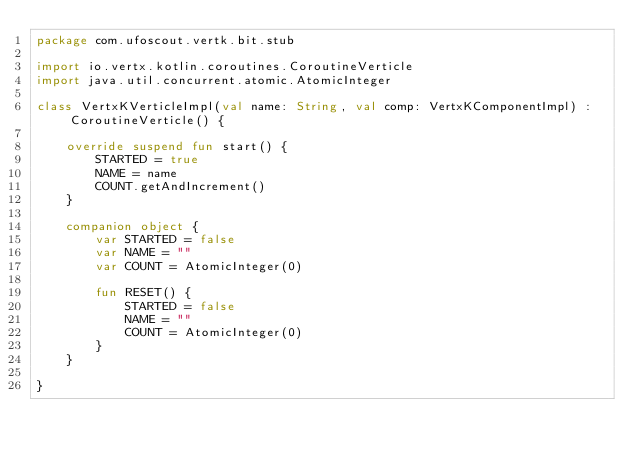<code> <loc_0><loc_0><loc_500><loc_500><_Kotlin_>package com.ufoscout.vertk.bit.stub

import io.vertx.kotlin.coroutines.CoroutineVerticle
import java.util.concurrent.atomic.AtomicInteger

class VertxKVerticleImpl(val name: String, val comp: VertxKComponentImpl) : CoroutineVerticle() {

    override suspend fun start() {
        STARTED = true
        NAME = name
        COUNT.getAndIncrement()
    }

    companion object {
        var STARTED = false
        var NAME = ""
        var COUNT = AtomicInteger(0)

        fun RESET() {
            STARTED = false
            NAME = ""
            COUNT = AtomicInteger(0)
        }
    }

}</code> 